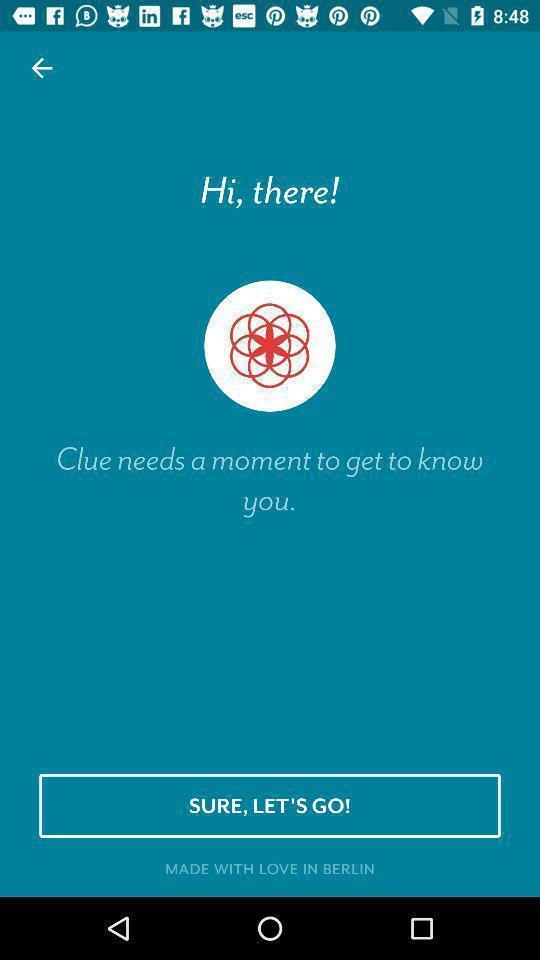What details can you identify in this image? Welcome page. 